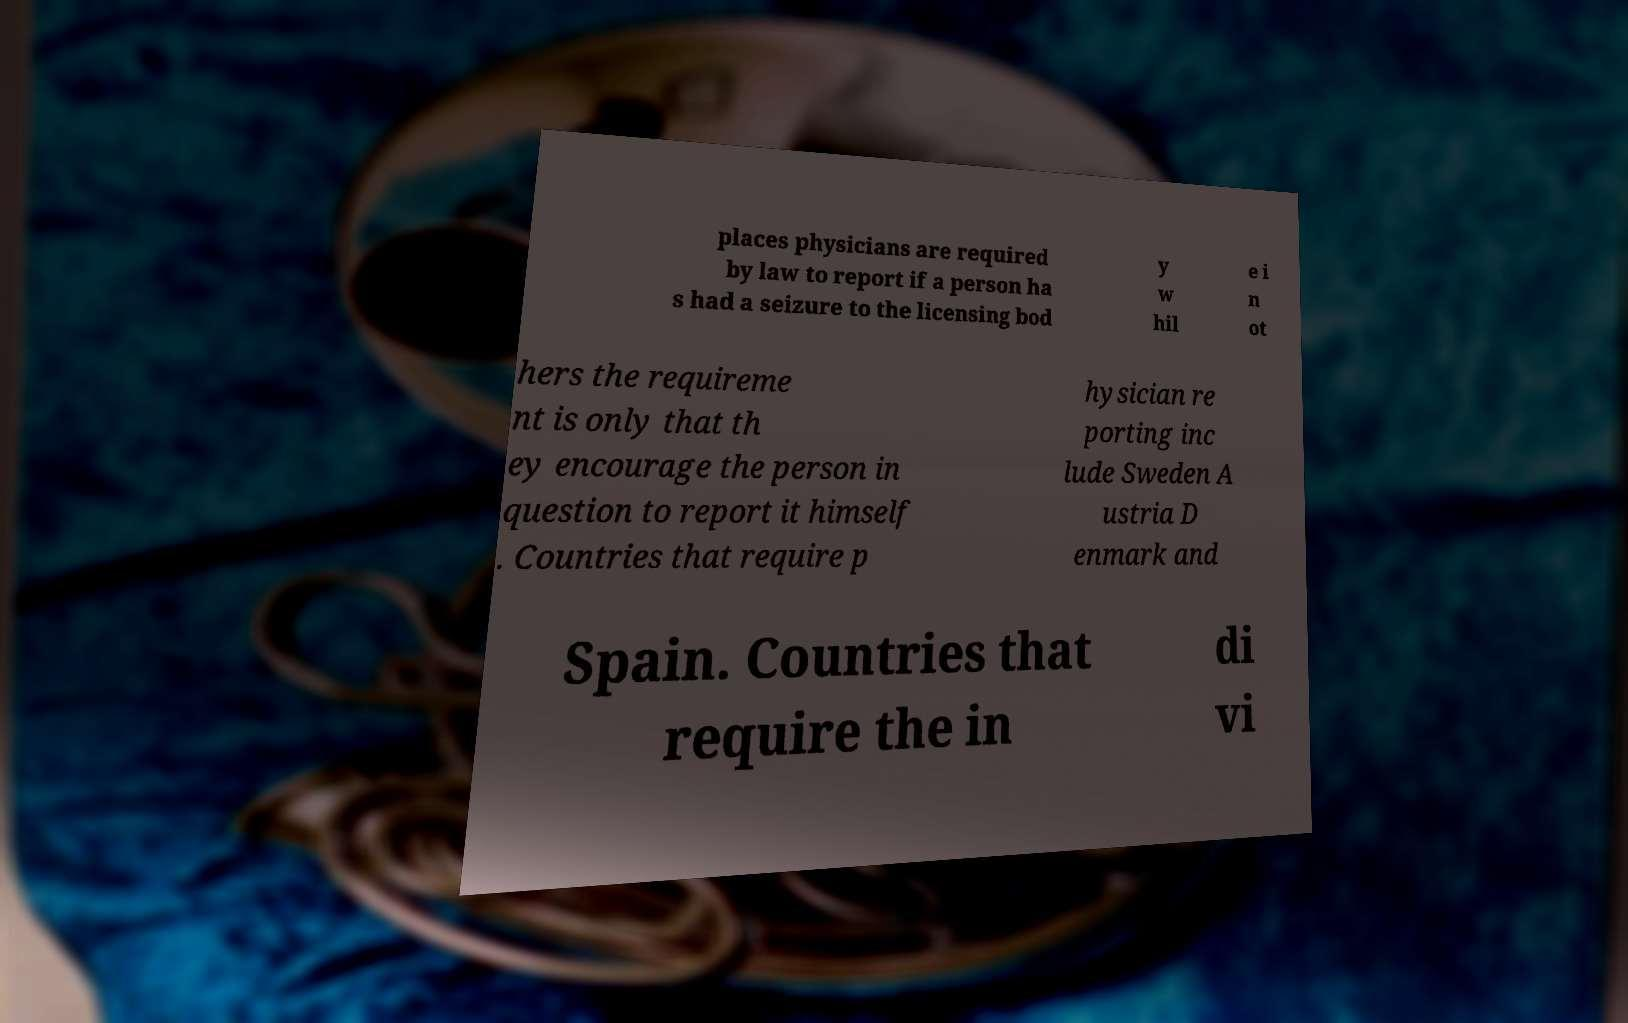Could you extract and type out the text from this image? places physicians are required by law to report if a person ha s had a seizure to the licensing bod y w hil e i n ot hers the requireme nt is only that th ey encourage the person in question to report it himself . Countries that require p hysician re porting inc lude Sweden A ustria D enmark and Spain. Countries that require the in di vi 